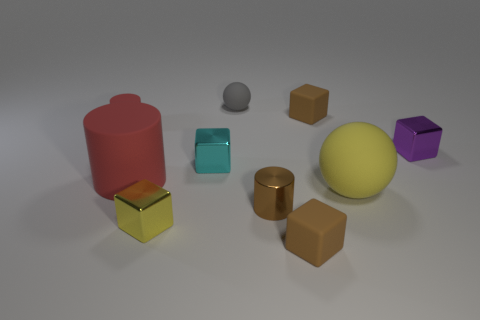Is there a cyan shiny object to the left of the shiny thing that is to the left of the cyan cube?
Keep it short and to the point. No. What color is the big matte thing that is on the right side of the gray rubber sphere?
Make the answer very short. Yellow. Are there the same number of small cyan things on the left side of the tiny red matte object and red rubber objects?
Ensure brevity in your answer.  No. There is a thing that is left of the small shiny cylinder and to the right of the small cyan block; what shape is it?
Your answer should be compact. Sphere. There is another large thing that is the same shape as the gray rubber thing; what color is it?
Your answer should be compact. Yellow. Are there any other things that have the same color as the large matte cylinder?
Make the answer very short. Yes. The small rubber thing behind the small rubber block that is behind the matte cube that is in front of the small matte cylinder is what shape?
Keep it short and to the point. Sphere. There is a brown cube in front of the large cylinder; is it the same size as the matte block behind the purple metallic cube?
Provide a succinct answer. Yes. How many large blue spheres have the same material as the tiny sphere?
Your answer should be very brief. 0. What number of gray things are behind the small brown matte block that is in front of the matte block that is behind the tiny purple shiny cube?
Give a very brief answer. 1. 